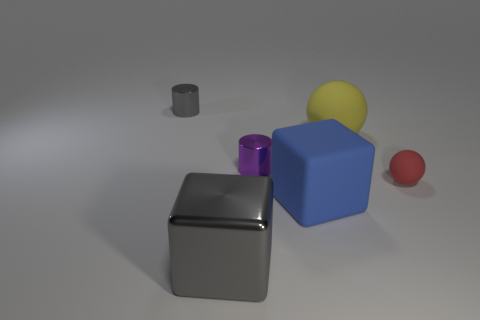Add 4 tiny brown metallic things. How many objects exist? 10 Subtract all blocks. How many objects are left? 4 Subtract 0 red cylinders. How many objects are left? 6 Subtract all cubes. Subtract all big objects. How many objects are left? 1 Add 5 tiny matte objects. How many tiny matte objects are left? 6 Add 2 large matte spheres. How many large matte spheres exist? 3 